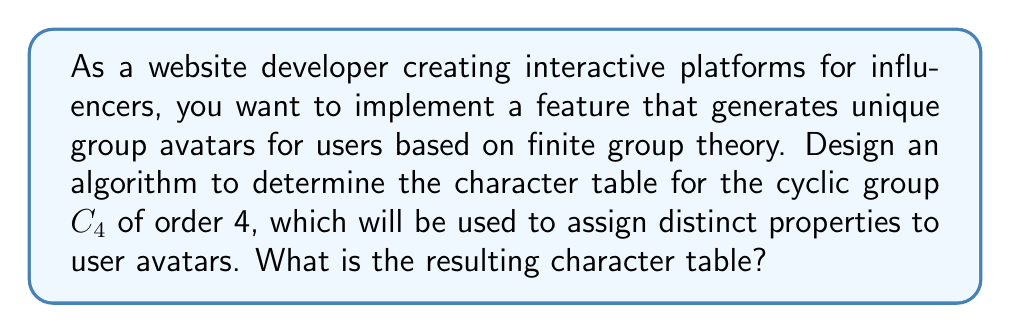Teach me how to tackle this problem. Let's determine the character table for the cyclic group $C_4$ step by step:

1) First, recall that $C_4 = \{e, a, a^2, a^3\}$, where $e$ is the identity element and $a$ is a generator of the group.

2) The number of irreducible representations (and thus the number of rows in the character table) is equal to the number of conjugacy classes. In a cyclic group, each element forms its own conjugacy class, so we have 4 irreducible representations.

3) Let's label our irreducible representations as $\chi_0, \chi_1, \chi_2, \chi_3$.

4) $\chi_0$ is always the trivial representation, which maps every element to 1.

5) For the other representations, we can use the fact that irreducible representations of cyclic groups are always one-dimensional. They are given by:

   $$\chi_j(a^k) = (\omega^j)^k = e^{2\pi ijk/4}$$

   where $\omega = e^{2\pi i/4} = i$ is a primitive 4th root of unity.

6) Calculating the values:
   
   For $\chi_1$: $\chi_1(e) = 1$, $\chi_1(a) = i$, $\chi_1(a^2) = i^2 = -1$, $\chi_1(a^3) = i^3 = -i$
   
   For $\chi_2$: $\chi_2(e) = 1$, $\chi_2(a) = i^2 = -1$, $\chi_2(a^2) = (-1)^2 = 1$, $\chi_2(a^3) = (-1)^3 = -1$
   
   For $\chi_3$: $\chi_3(e) = 1$, $\chi_3(a) = i^3 = -i$, $\chi_3(a^2) = (-i)^2 = -1$, $\chi_3(a^3) = (-i)^3 = i$

7) We can now construct the character table:

   $$\begin{array}{c|cccc}
      C_4 & e & a & a^2 & a^3 \\
      \hline
      \chi_0 & 1 & 1 & 1 & 1 \\
      \chi_1 & 1 & i & -1 & -i \\
      \chi_2 & 1 & -1 & 1 & -1 \\
      \chi_3 & 1 & -i & -1 & i
   \end{array}$$

This character table can be used to assign unique properties to user avatars based on their group membership in your interactive platform.
Answer: $$\begin{array}{c|cccc}
C_4 & e & a & a^2 & a^3 \\
\hline
\chi_0 & 1 & 1 & 1 & 1 \\
\chi_1 & 1 & i & -1 & -i \\
\chi_2 & 1 & -1 & 1 & -1 \\
\chi_3 & 1 & -i & -1 & i
\end{array}$$ 